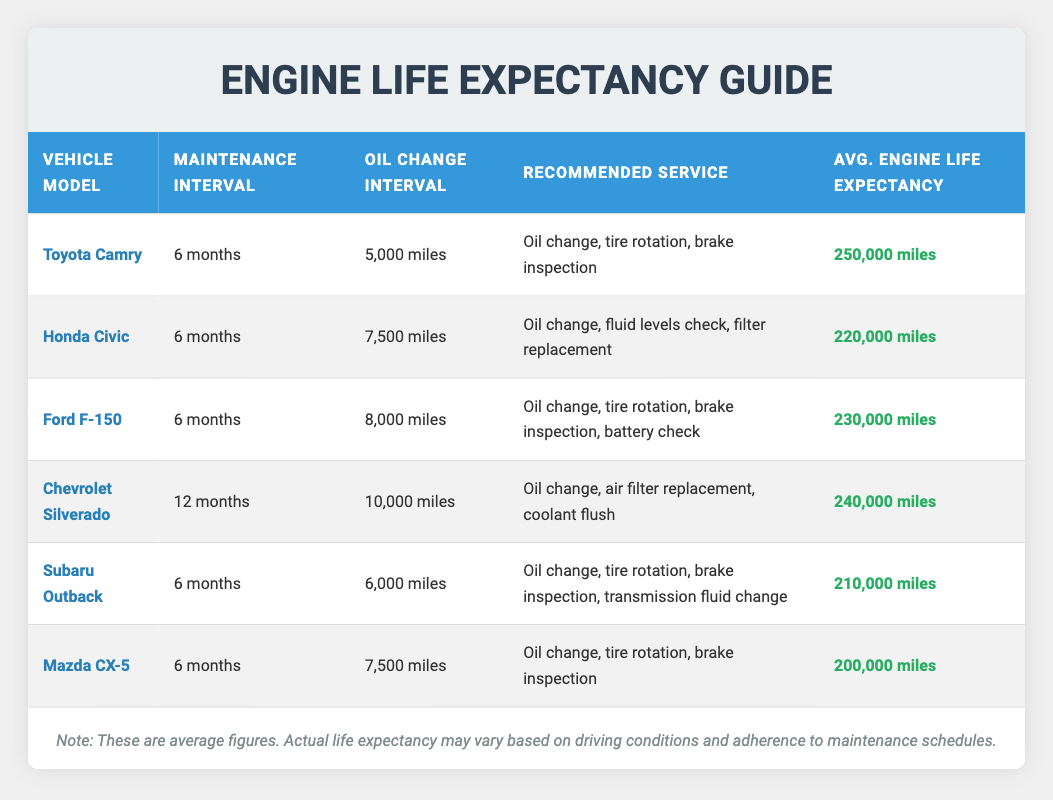What is the average engine life expectancy for the Honda Civic? From the table, we can directly find that the average engine life expectancy for the Honda Civic is listed as 220,000 miles.
Answer: 220,000 miles How often should maintenance be performed on a Toyota Camry? The maintenance interval for a Toyota Camry is specified in the table as every 6 months.
Answer: Every 6 months Which vehicle model has the longest average engine life expectancy? In the table, the vehicle with the longest average engine life expectancy is the Toyota Camry at 250,000 miles.
Answer: Toyota Camry If I perform maintenance on my Chevrolet Silverado every 6 months, would that be less frequent than recommended? The table shows that the recommended maintenance interval for the Chevrolet Silverado is every 12 months. Therefore, performing maintenance every 6 months would be more frequent than recommended.
Answer: Yes What is the difference in average engine life expectancy between the Ford F-150 and the Mazda CX-5? From the table, the average engine life expectancy for the Ford F-150 is 230,000 miles, and for the Mazda CX-5, it is 200,000 miles. The difference is 230,000 - 200,000 = 30,000 miles.
Answer: 30,000 miles What are the recommended services for the Subaru Outback? The recommended services for the Subaru Outback listed in the table include: oil change, tire rotation, brake inspection, and transmission fluid change.
Answer: Oil change, tire rotation, brake inspection, transmission fluid change Is it true that both the Honda Civic and Mazda CX-5 recommend an oil change every 7,500 miles? According to the table, the Honda Civic recommends an oil change every 7,500 miles, while the Mazda CX-5 recommends it every 7,500 miles. Thus, it is true that both recommend the same interval.
Answer: Yes How many vehicles in the table have a maintenance interval of 6 months? By reviewing the table, we find that there are four vehicles with a maintenance interval of 6 months: Toyota Camry, Honda Civic, Ford F-150, and Subaru Outback. Therefore, the answer is 4.
Answer: 4 If I average the engine life expectancies of the Honda Civic and Ford F-150, what would that be? The average engine life expectancy of the Honda Civic is 220,000 miles and that of the Ford F-150 is 230,000 miles. To find the average: (220,000 + 230,000) / 2 = 225,000 miles.
Answer: 225,000 miles 